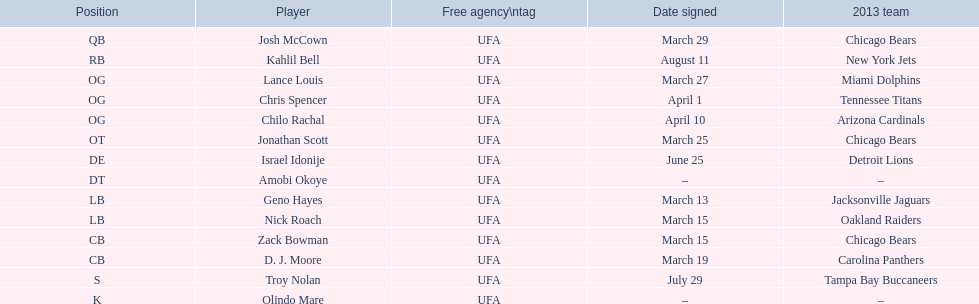What's the count of players participating as cb or og? 5. 